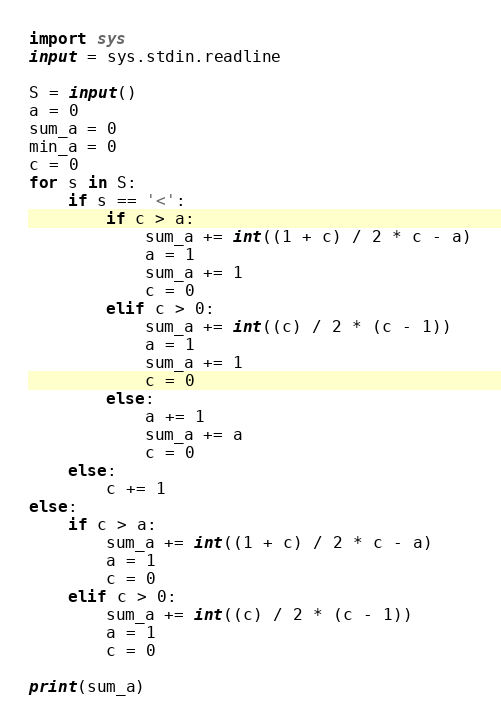<code> <loc_0><loc_0><loc_500><loc_500><_Python_>import sys
input = sys.stdin.readline

S = input()
a = 0
sum_a = 0
min_a = 0
c = 0
for s in S:
    if s == '<':
        if c > a:
            sum_a += int((1 + c) / 2 * c - a)
            a = 1
            sum_a += 1
            c = 0
        elif c > 0:
            sum_a += int((c) / 2 * (c - 1))
            a = 1
            sum_a += 1
            c = 0
        else:
            a += 1
            sum_a += a
            c = 0
    else:
        c += 1
else:
    if c > a:
        sum_a += int((1 + c) / 2 * c - a)
        a = 1
        c = 0
    elif c > 0:
        sum_a += int((c) / 2 * (c - 1))
        a = 1
        c = 0

print(sum_a)
</code> 